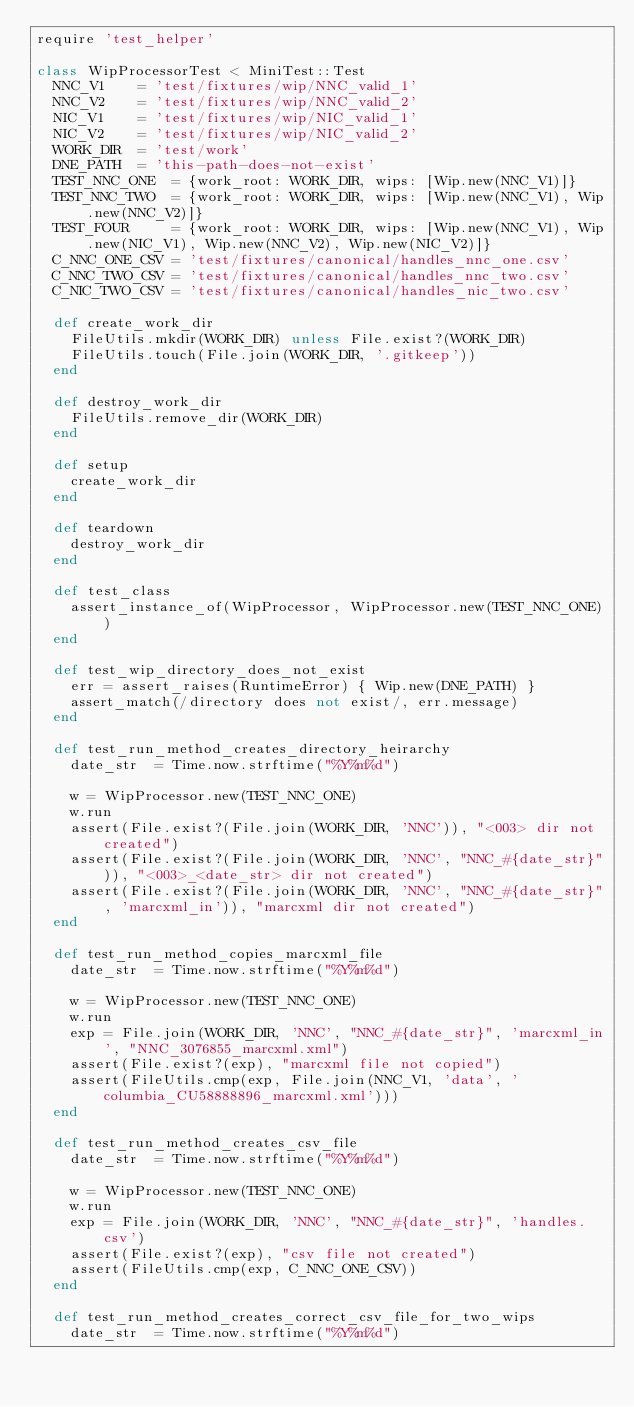<code> <loc_0><loc_0><loc_500><loc_500><_Ruby_>require 'test_helper'

class WipProcessorTest < MiniTest::Test
  NNC_V1    = 'test/fixtures/wip/NNC_valid_1'
  NNC_V2    = 'test/fixtures/wip/NNC_valid_2'
  NIC_V1    = 'test/fixtures/wip/NIC_valid_1'
  NIC_V2    = 'test/fixtures/wip/NIC_valid_2'
  WORK_DIR  = 'test/work'
  DNE_PATH  = 'this-path-does-not-exist'
  TEST_NNC_ONE  = {work_root: WORK_DIR, wips: [Wip.new(NNC_V1)]}
  TEST_NNC_TWO  = {work_root: WORK_DIR, wips: [Wip.new(NNC_V1), Wip.new(NNC_V2)]}
  TEST_FOUR     = {work_root: WORK_DIR, wips: [Wip.new(NNC_V1), Wip.new(NIC_V1), Wip.new(NNC_V2), Wip.new(NIC_V2)]}
  C_NNC_ONE_CSV = 'test/fixtures/canonical/handles_nnc_one.csv'
  C_NNC_TWO_CSV = 'test/fixtures/canonical/handles_nnc_two.csv'
  C_NIC_TWO_CSV = 'test/fixtures/canonical/handles_nic_two.csv'

  def create_work_dir
    FileUtils.mkdir(WORK_DIR) unless File.exist?(WORK_DIR)
    FileUtils.touch(File.join(WORK_DIR, '.gitkeep'))
  end

  def destroy_work_dir
    FileUtils.remove_dir(WORK_DIR)
  end

  def setup
    create_work_dir
  end

  def teardown
    destroy_work_dir
  end

  def test_class
    assert_instance_of(WipProcessor, WipProcessor.new(TEST_NNC_ONE))
  end

  def test_wip_directory_does_not_exist
    err = assert_raises(RuntimeError) { Wip.new(DNE_PATH) }
    assert_match(/directory does not exist/, err.message)
  end

  def test_run_method_creates_directory_heirarchy
    date_str  = Time.now.strftime("%Y%m%d")

    w = WipProcessor.new(TEST_NNC_ONE)
    w.run
    assert(File.exist?(File.join(WORK_DIR, 'NNC')), "<003> dir not created")
    assert(File.exist?(File.join(WORK_DIR, 'NNC', "NNC_#{date_str}")), "<003>_<date_str> dir not created")
    assert(File.exist?(File.join(WORK_DIR, 'NNC', "NNC_#{date_str}", 'marcxml_in')), "marcxml dir not created")
  end

  def test_run_method_copies_marcxml_file
    date_str  = Time.now.strftime("%Y%m%d")

    w = WipProcessor.new(TEST_NNC_ONE)
    w.run
    exp = File.join(WORK_DIR, 'NNC', "NNC_#{date_str}", 'marcxml_in', "NNC_3076855_marcxml.xml")
    assert(File.exist?(exp), "marcxml file not copied")
    assert(FileUtils.cmp(exp, File.join(NNC_V1, 'data', 'columbia_CU58888896_marcxml.xml')))
  end

  def test_run_method_creates_csv_file
    date_str  = Time.now.strftime("%Y%m%d")

    w = WipProcessor.new(TEST_NNC_ONE)
    w.run
    exp = File.join(WORK_DIR, 'NNC', "NNC_#{date_str}", 'handles.csv')
    assert(File.exist?(exp), "csv file not created")
    assert(FileUtils.cmp(exp, C_NNC_ONE_CSV))
  end

  def test_run_method_creates_correct_csv_file_for_two_wips
    date_str  = Time.now.strftime("%Y%m%d")
</code> 